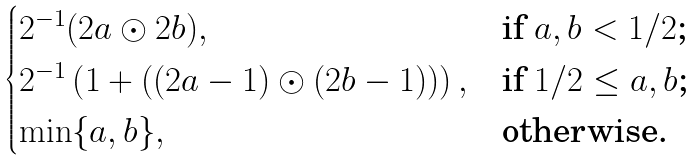<formula> <loc_0><loc_0><loc_500><loc_500>\begin{cases} 2 ^ { - 1 } ( 2 a \odot 2 b ) , & \text {if $a,b<1/2$;} \\ 2 ^ { - 1 } \left ( 1 + ( ( 2 a - 1 ) \odot ( 2 b - 1 ) ) \right ) , & \text {if $1/2\leq a,b$;} \\ \min \{ a , b \} , & \text {otherwise.} \end{cases}</formula> 